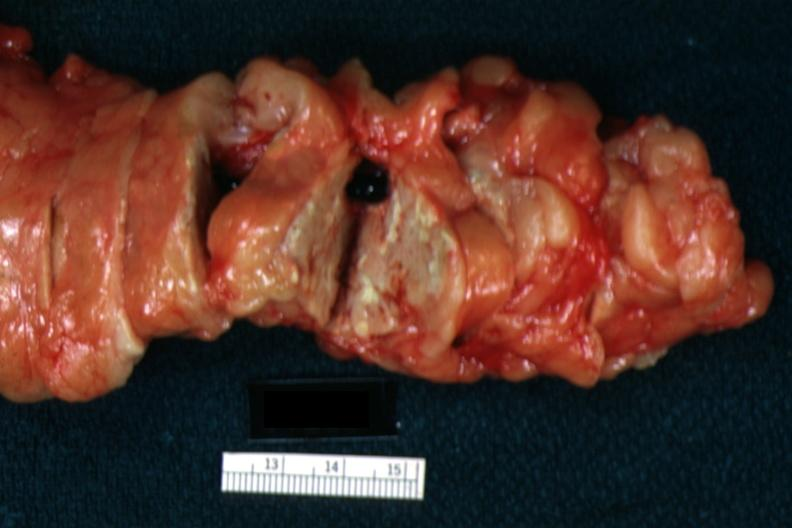what is present?
Answer the question using a single word or phrase. Pancreas 